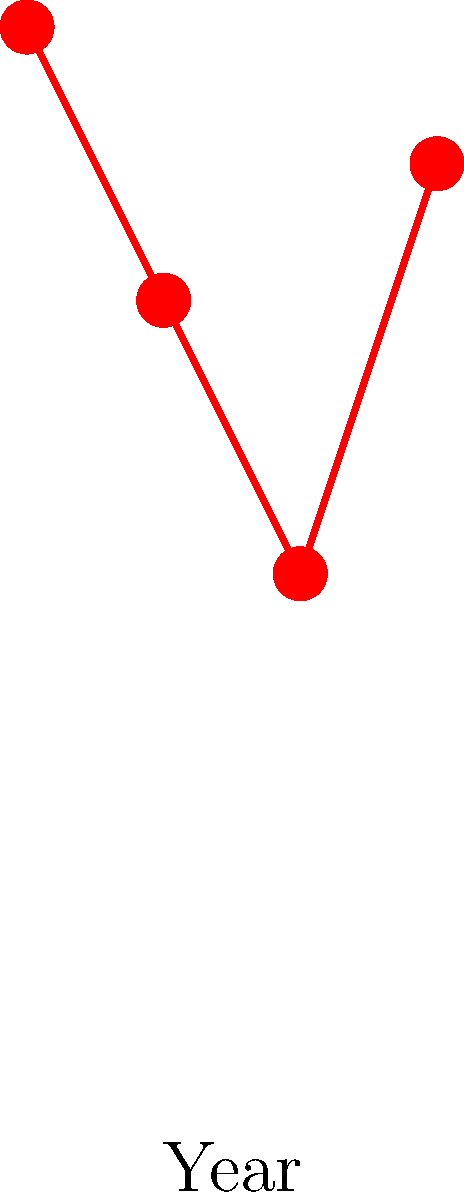Based on the graph showing the popularity of architectural styles in early 20th century Texas, which style experienced a significant resurgence in popularity between 1920 and 1930? To answer this question, we need to analyze the graph step-by-step:

1. The graph shows four architectural styles: Greek Revival, Victorian, Prairie, and Craftsman.
2. The x-axis represents years from 1900 to 1930, while the y-axis shows popularity percentage.
3. We need to focus on the period between 1920 and 1930.
4. Greek Revival: Starts high in 1900 but decreases steadily.
5. Victorian: Shows a continuous decline.
6. Prairie: Remains relatively low throughout the period.
7. Craftsman: Shows a significant increase from 1920 to 1930.

The Craftsman style is the only one that demonstrates a notable rise in popularity during the specified timeframe, increasing from about 40% in 1920 to 70% in 1930.
Answer: Craftsman 